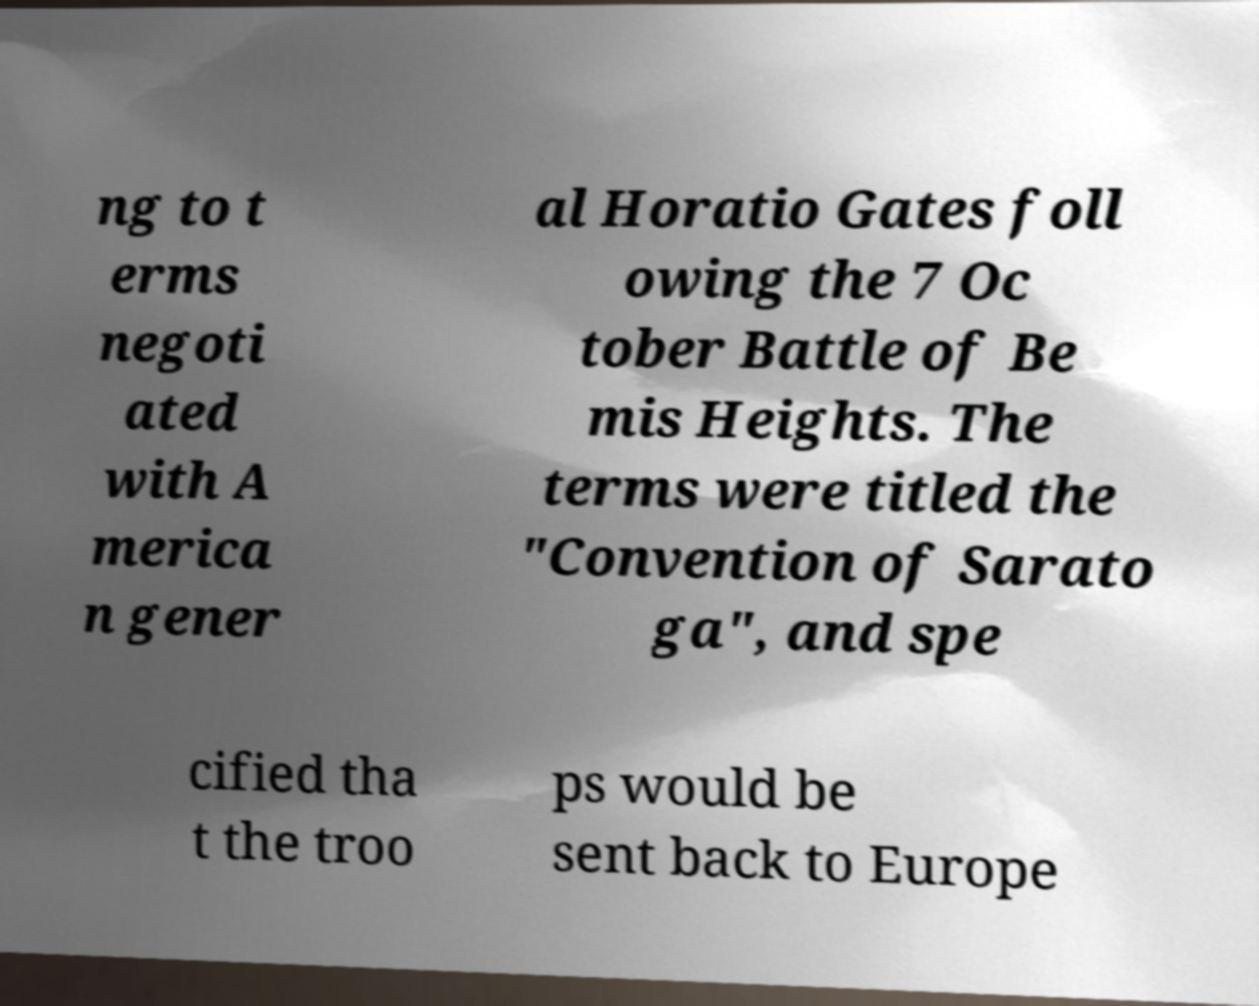For documentation purposes, I need the text within this image transcribed. Could you provide that? ng to t erms negoti ated with A merica n gener al Horatio Gates foll owing the 7 Oc tober Battle of Be mis Heights. The terms were titled the "Convention of Sarato ga", and spe cified tha t the troo ps would be sent back to Europe 